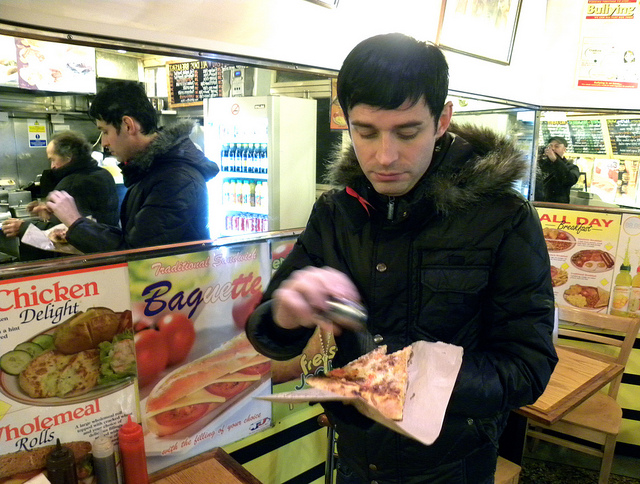What is he doing with the pizza? The gentleman appears to be in the midst of enhancing his slice of pizza, likely by adding a seasoning or spice to it. His focused demeanor suggests he is customized it to match his palate. Therefore, the correct response would be 'C. adding flavor'. 